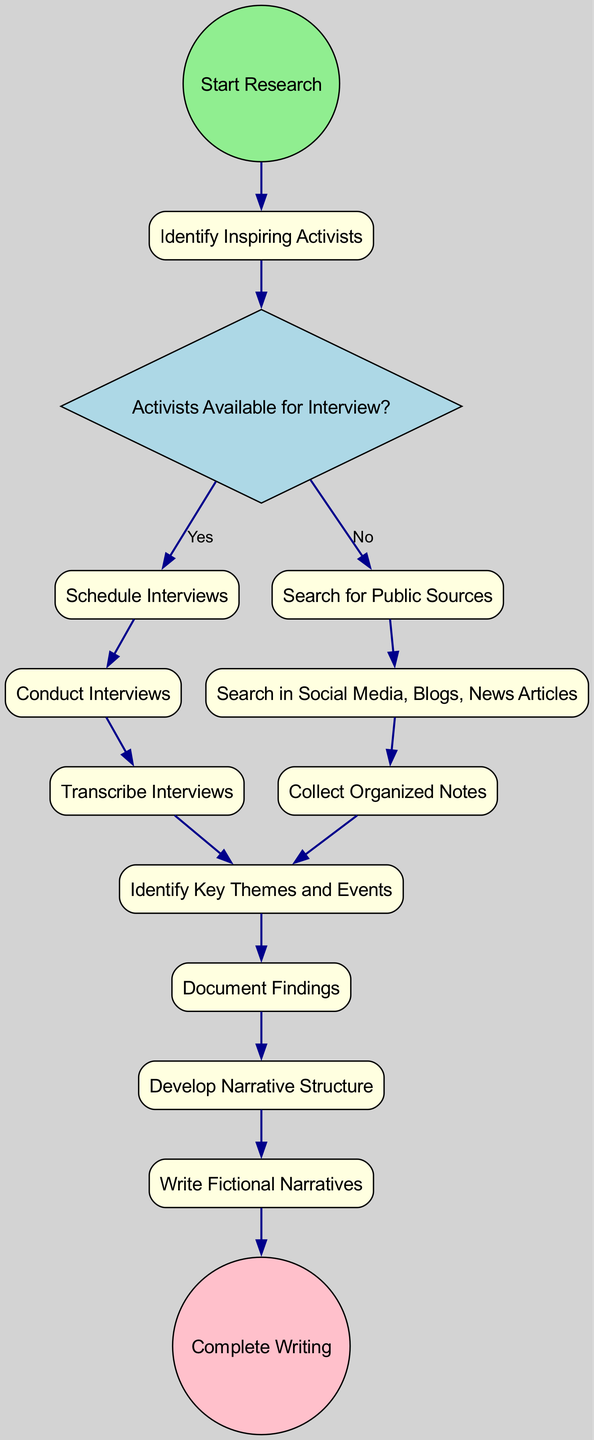What is the first step in the process? The diagram initiates with the node labeled "Start Research," indicating it is the first step in the gathering and organizing process.
Answer: Start Research How many decision points are present in the diagram? There is one decision point in the diagram, indicated by the diamond-shaped node titled "Activists Available for Interview?"
Answer: 1 What activity directly follows "Transcribe Interviews"? According to the diagram, the activity that comes after "Transcribe Interviews" is "Identify Key Themes and Events."
Answer: Identify Key Themes and Events What happens if no activists are available for interview? If there are no activists available for interview, the flow leads to the activity "Search for Public Sources," as outlined in the decision options from the decision point.
Answer: Search for Public Sources Which activity leads to "Document Findings"? The activities "Collect Organized Notes" and "Transcribe Interviews" both lead to the activity "Identify Key Themes and Events," which then leads to "Document Findings."
Answer: Identify Key Themes and Events Which node concludes the entire process? The process concludes with the node labeled "Complete Writing," which is represented as an end event in the diagram.
Answer: Complete Writing What is the last step before writing fictional narratives? The last step before writing fictional narratives is "Develop Narrative Structure." This is shown as the activity that precedes it in the flow.
Answer: Develop Narrative Structure How is information collected from social media, blogs, and news articles? Information is collected through the activity labeled "Search in Social Media, Blogs, News Articles," which is directly linked from the decision path when no interviews are scheduled.
Answer: Search in Social Media, Blogs, News Articles How are interview findings processed after they are conducted? After conducting interviews, the findings are transcribed in the "Transcribe Interviews" activity, which then leads to "Identify Key Themes and Events."
Answer: Transcribe Interviews 